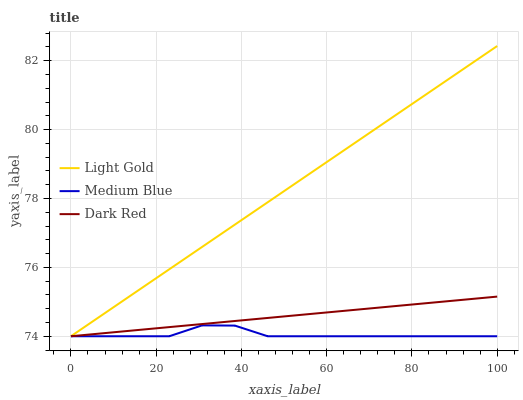Does Dark Red have the minimum area under the curve?
Answer yes or no. No. Does Dark Red have the maximum area under the curve?
Answer yes or no. No. Is Light Gold the smoothest?
Answer yes or no. No. Is Light Gold the roughest?
Answer yes or no. No. Does Dark Red have the highest value?
Answer yes or no. No. 